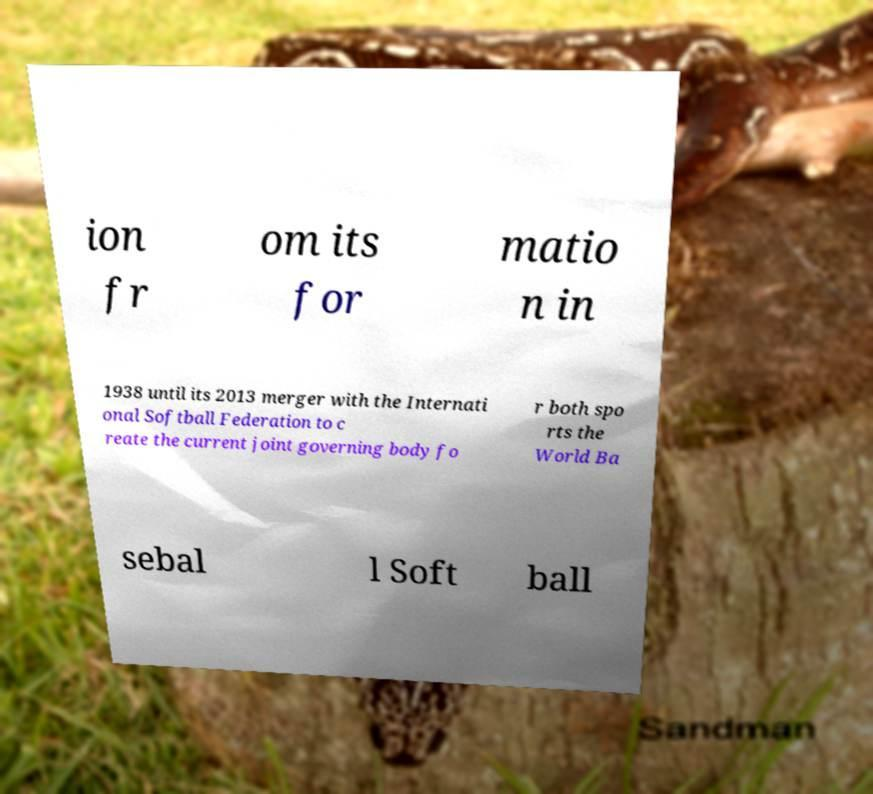Can you read and provide the text displayed in the image?This photo seems to have some interesting text. Can you extract and type it out for me? ion fr om its for matio n in 1938 until its 2013 merger with the Internati onal Softball Federation to c reate the current joint governing body fo r both spo rts the World Ba sebal l Soft ball 